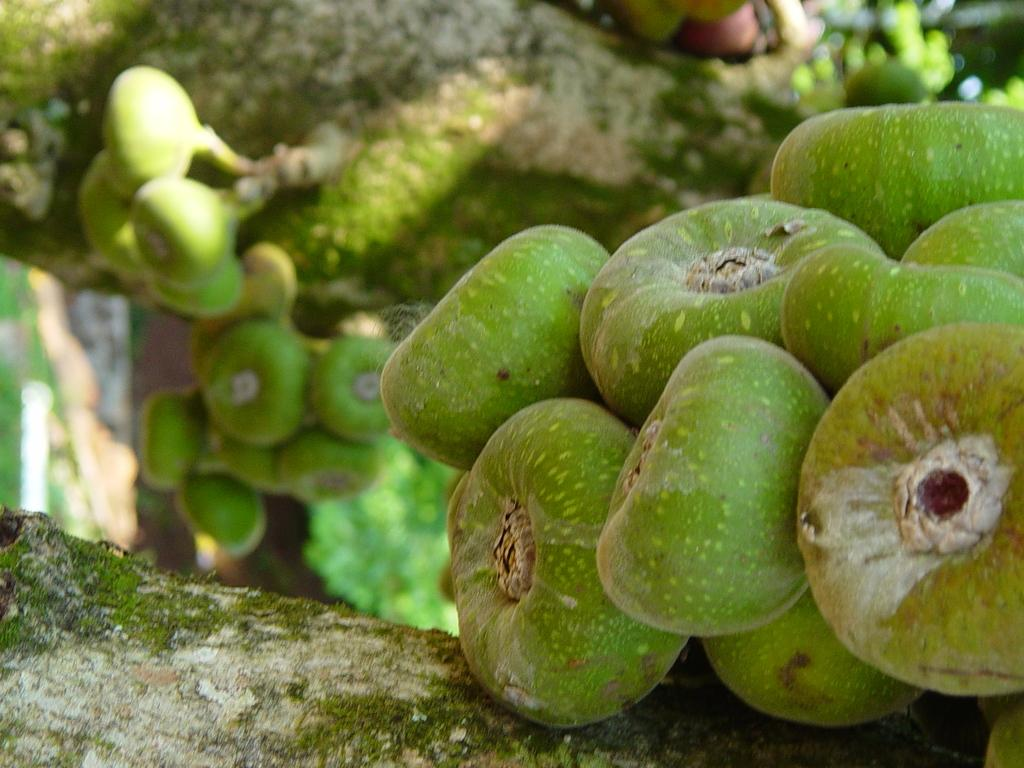What type of plant can be seen in the image? There is a tree in the image. What is growing on the tree? There are fruits visible in the image. What type of chairs are depicted in the image? There are no chairs present in the image; it only features a tree with fruits. 